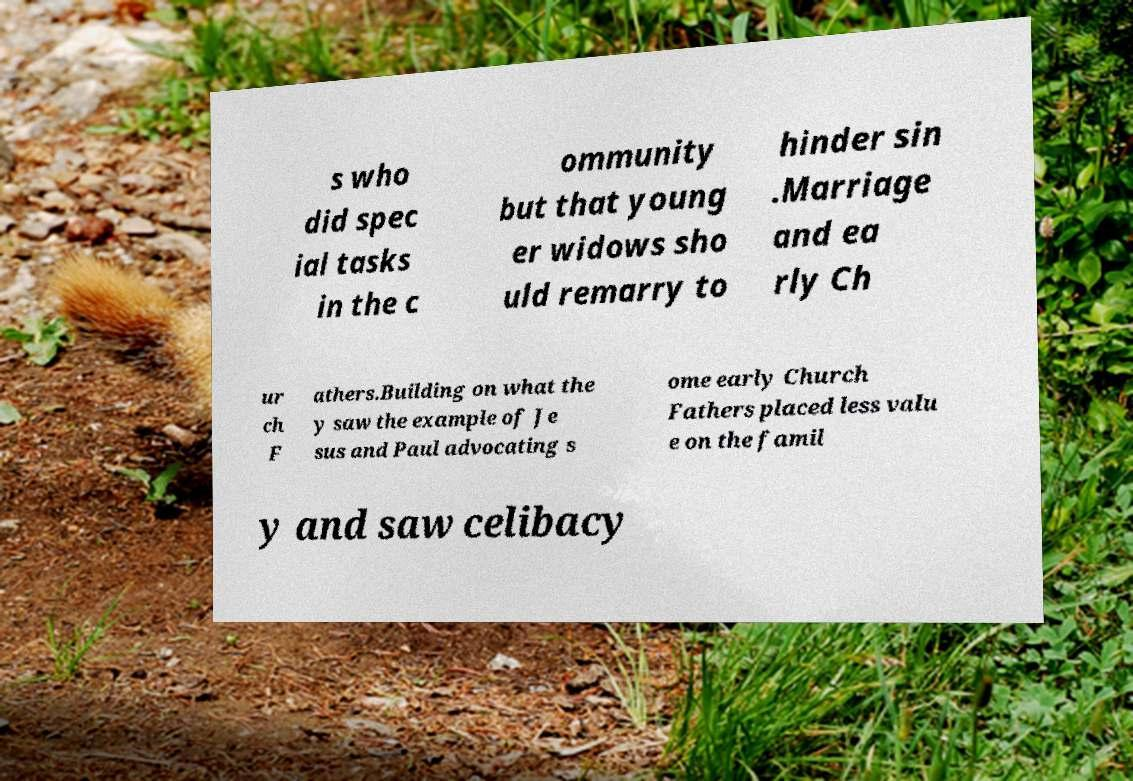I need the written content from this picture converted into text. Can you do that? s who did spec ial tasks in the c ommunity but that young er widows sho uld remarry to hinder sin .Marriage and ea rly Ch ur ch F athers.Building on what the y saw the example of Je sus and Paul advocating s ome early Church Fathers placed less valu e on the famil y and saw celibacy 